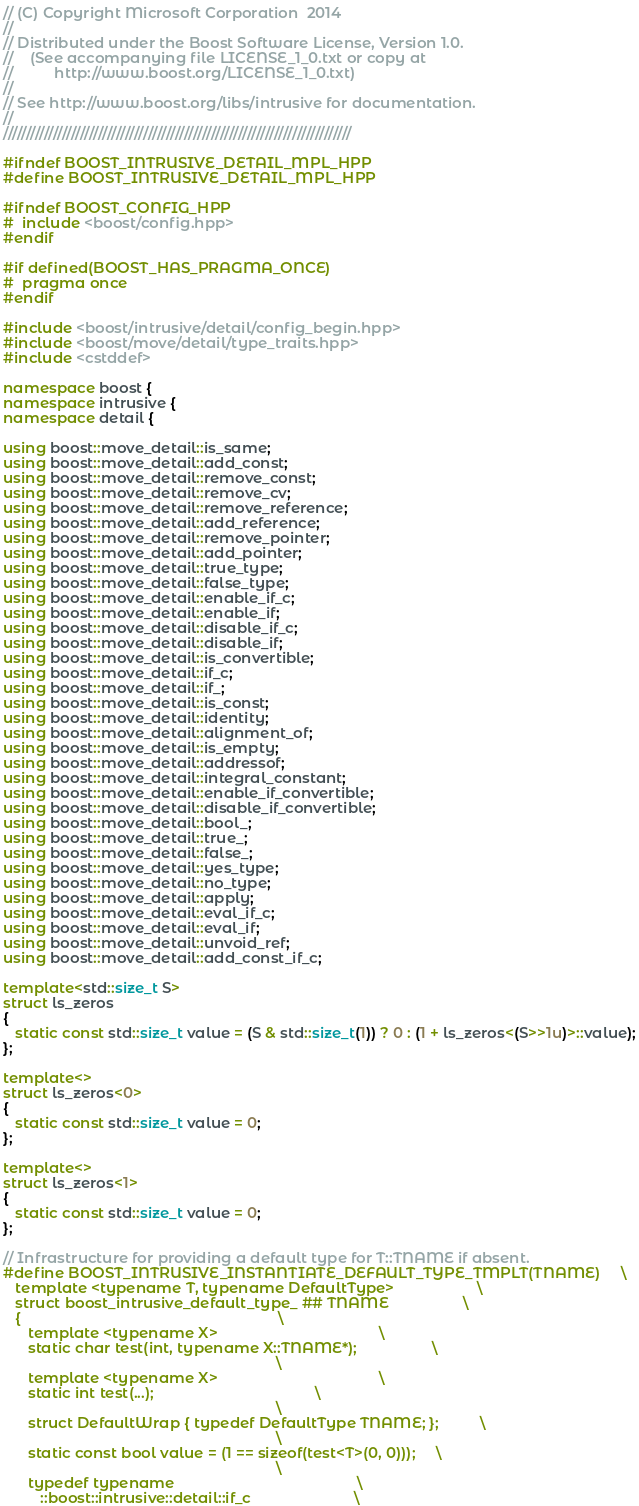Convert code to text. <code><loc_0><loc_0><loc_500><loc_500><_C++_>// (C) Copyright Microsoft Corporation  2014
//
// Distributed under the Boost Software License, Version 1.0.
//    (See accompanying file LICENSE_1_0.txt or copy at
//          http://www.boost.org/LICENSE_1_0.txt)
//
// See http://www.boost.org/libs/intrusive for documentation.
//
/////////////////////////////////////////////////////////////////////////////

#ifndef BOOST_INTRUSIVE_DETAIL_MPL_HPP
#define BOOST_INTRUSIVE_DETAIL_MPL_HPP

#ifndef BOOST_CONFIG_HPP
#  include <boost/config.hpp>
#endif

#if defined(BOOST_HAS_PRAGMA_ONCE)
#  pragma once
#endif

#include <boost/intrusive/detail/config_begin.hpp>
#include <boost/move/detail/type_traits.hpp>
#include <cstddef>

namespace boost {
namespace intrusive {
namespace detail {

using boost::move_detail::is_same;
using boost::move_detail::add_const;
using boost::move_detail::remove_const;
using boost::move_detail::remove_cv;
using boost::move_detail::remove_reference;
using boost::move_detail::add_reference;
using boost::move_detail::remove_pointer;
using boost::move_detail::add_pointer;
using boost::move_detail::true_type;
using boost::move_detail::false_type;
using boost::move_detail::enable_if_c;
using boost::move_detail::enable_if;
using boost::move_detail::disable_if_c;
using boost::move_detail::disable_if;
using boost::move_detail::is_convertible;
using boost::move_detail::if_c;
using boost::move_detail::if_;
using boost::move_detail::is_const;
using boost::move_detail::identity;
using boost::move_detail::alignment_of;
using boost::move_detail::is_empty;
using boost::move_detail::addressof;
using boost::move_detail::integral_constant;
using boost::move_detail::enable_if_convertible;
using boost::move_detail::disable_if_convertible;
using boost::move_detail::bool_;
using boost::move_detail::true_;
using boost::move_detail::false_;
using boost::move_detail::yes_type;
using boost::move_detail::no_type;
using boost::move_detail::apply;
using boost::move_detail::eval_if_c;
using boost::move_detail::eval_if;
using boost::move_detail::unvoid_ref;
using boost::move_detail::add_const_if_c;

template<std::size_t S>
struct ls_zeros
{
   static const std::size_t value = (S & std::size_t(1)) ? 0 : (1 + ls_zeros<(S>>1u)>::value);
};

template<>
struct ls_zeros<0>
{
   static const std::size_t value = 0;
};

template<>
struct ls_zeros<1>
{
   static const std::size_t value = 0;
};

// Infrastructure for providing a default type for T::TNAME if absent.
#define BOOST_INTRUSIVE_INSTANTIATE_DEFAULT_TYPE_TMPLT(TNAME)     \
   template <typename T, typename DefaultType>                    \
   struct boost_intrusive_default_type_ ## TNAME                  \
   {                                                              \
      template <typename X>                                       \
      static char test(int, typename X::TNAME*);                  \
                                                                  \
      template <typename X>                                       \
      static int test(...);                                       \
                                                                  \
      struct DefaultWrap { typedef DefaultType TNAME; };          \
                                                                  \
      static const bool value = (1 == sizeof(test<T>(0, 0)));     \
                                                                  \
      typedef typename                                            \
         ::boost::intrusive::detail::if_c                         \</code> 